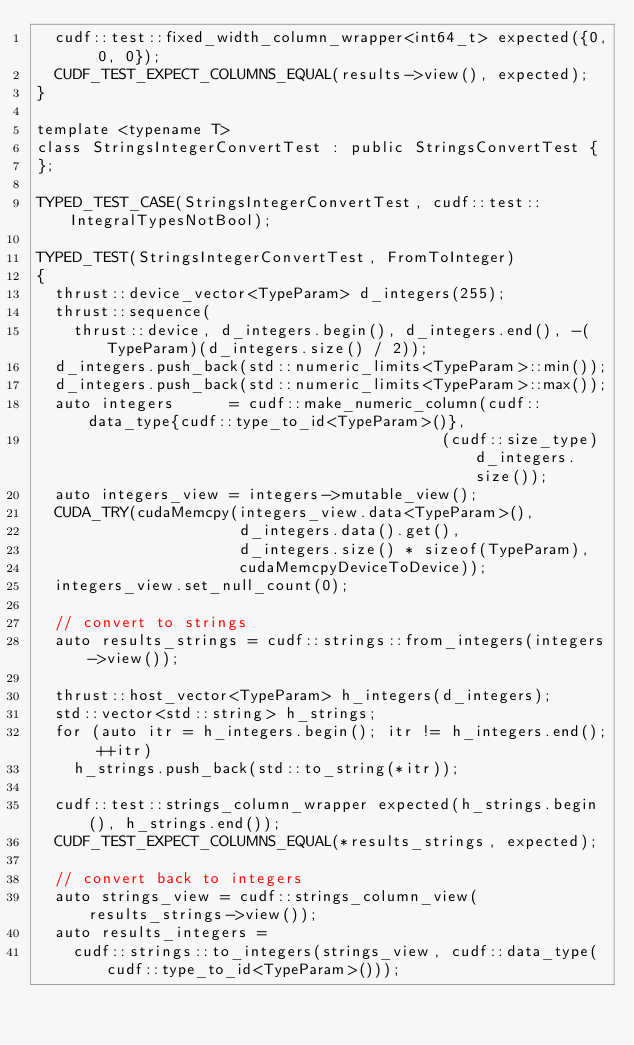Convert code to text. <code><loc_0><loc_0><loc_500><loc_500><_Cuda_>  cudf::test::fixed_width_column_wrapper<int64_t> expected({0, 0, 0});
  CUDF_TEST_EXPECT_COLUMNS_EQUAL(results->view(), expected);
}

template <typename T>
class StringsIntegerConvertTest : public StringsConvertTest {
};

TYPED_TEST_CASE(StringsIntegerConvertTest, cudf::test::IntegralTypesNotBool);

TYPED_TEST(StringsIntegerConvertTest, FromToInteger)
{
  thrust::device_vector<TypeParam> d_integers(255);
  thrust::sequence(
    thrust::device, d_integers.begin(), d_integers.end(), -(TypeParam)(d_integers.size() / 2));
  d_integers.push_back(std::numeric_limits<TypeParam>::min());
  d_integers.push_back(std::numeric_limits<TypeParam>::max());
  auto integers      = cudf::make_numeric_column(cudf::data_type{cudf::type_to_id<TypeParam>()},
                                            (cudf::size_type)d_integers.size());
  auto integers_view = integers->mutable_view();
  CUDA_TRY(cudaMemcpy(integers_view.data<TypeParam>(),
                      d_integers.data().get(),
                      d_integers.size() * sizeof(TypeParam),
                      cudaMemcpyDeviceToDevice));
  integers_view.set_null_count(0);

  // convert to strings
  auto results_strings = cudf::strings::from_integers(integers->view());

  thrust::host_vector<TypeParam> h_integers(d_integers);
  std::vector<std::string> h_strings;
  for (auto itr = h_integers.begin(); itr != h_integers.end(); ++itr)
    h_strings.push_back(std::to_string(*itr));

  cudf::test::strings_column_wrapper expected(h_strings.begin(), h_strings.end());
  CUDF_TEST_EXPECT_COLUMNS_EQUAL(*results_strings, expected);

  // convert back to integers
  auto strings_view = cudf::strings_column_view(results_strings->view());
  auto results_integers =
    cudf::strings::to_integers(strings_view, cudf::data_type(cudf::type_to_id<TypeParam>()));</code> 